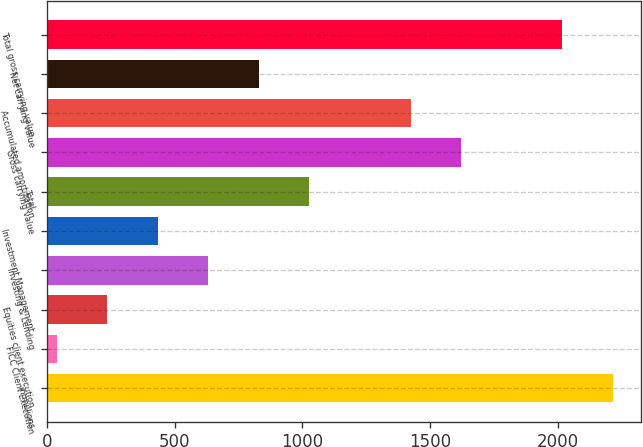Convert chart. <chart><loc_0><loc_0><loc_500><loc_500><bar_chart><fcel>in millions<fcel>FICC Client Execution<fcel>Equities client execution<fcel>Investing & Lending<fcel>Investment Management<fcel>Total<fcel>Gross carrying value<fcel>Accumulated amortization<fcel>Net carrying value<fcel>Total gross carrying value<nl><fcel>2215<fcel>37<fcel>235<fcel>631<fcel>433<fcel>1027<fcel>1621<fcel>1423<fcel>829<fcel>2017<nl></chart> 